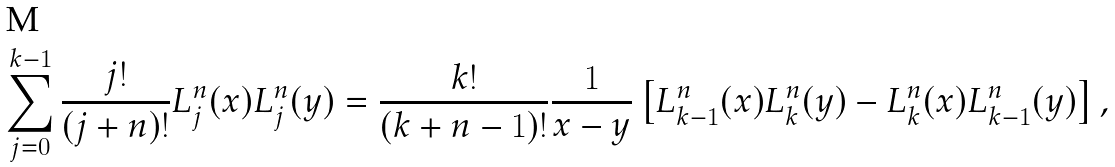<formula> <loc_0><loc_0><loc_500><loc_500>\sum _ { j = 0 } ^ { k - 1 } \frac { j ! } { ( j + n ) ! } L _ { j } ^ { n } ( x ) L _ { j } ^ { n } ( y ) = \frac { k ! } { ( k + n - 1 ) ! } \frac { 1 } { x - y } \left [ L _ { k - 1 } ^ { n } ( x ) L _ { k } ^ { n } ( y ) - L _ { k } ^ { n } ( x ) L _ { k - 1 } ^ { n } ( y ) \right ] ,</formula> 